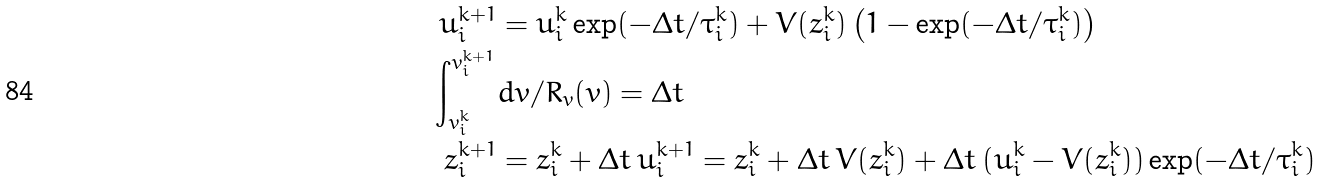Convert formula to latex. <formula><loc_0><loc_0><loc_500><loc_500>u _ { i } ^ { k + 1 } & = u _ { i } ^ { k } \exp ( { - \Delta t / \tau _ { i } ^ { k } } ) + V ( z _ { i } ^ { k } ) \left ( 1 - \exp ( { - \Delta t / \tau _ { i } ^ { k } } ) \right ) \\ \int _ { v _ { i } ^ { k } } ^ { v _ { i } ^ { k + 1 } } & d v / R _ { v } ( v ) = \Delta t \\ z _ { i } ^ { k + 1 } & = z _ { i } ^ { k } + \Delta t \, u _ { i } ^ { k + 1 } = z _ { i } ^ { k } + \Delta t \, V ( z _ { i } ^ { k } ) + \Delta t \, ( u _ { i } ^ { k } - V ( z _ { i } ^ { k } ) ) \exp ( { - \Delta t / \tau _ { i } ^ { k } } )</formula> 